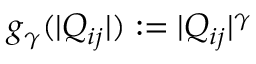<formula> <loc_0><loc_0><loc_500><loc_500>g _ { \gamma } ( | Q _ { i j } | ) \colon = | Q _ { i j } | ^ { \gamma }</formula> 